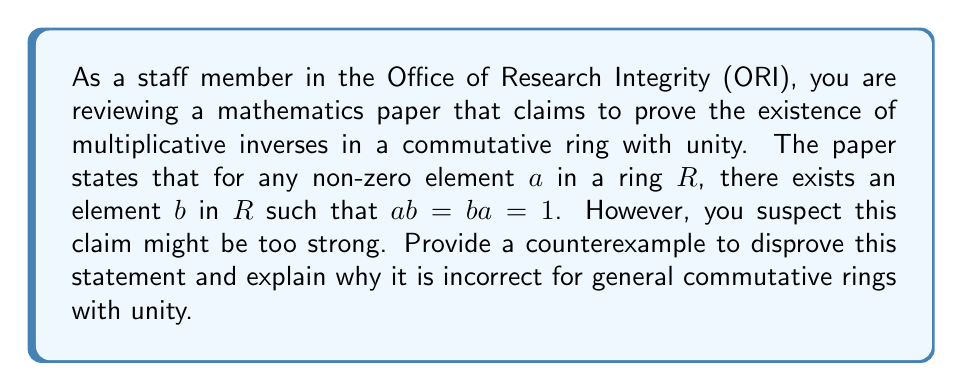Could you help me with this problem? To disprove the statement, we need to find a commutative ring with unity where not every non-zero element has a multiplicative inverse. Let's consider the ring of integers $\mathbb{Z}$ under standard addition and multiplication.

1. $\mathbb{Z}$ is a commutative ring with unity:
   - It is closed under addition and multiplication
   - Addition and multiplication are associative and commutative
   - Distributive property holds
   - $0$ is the additive identity
   - $1$ is the multiplicative identity (unity)

2. Consider the element $2 \in \mathbb{Z}$:
   - For $2$ to have a multiplicative inverse, we need to find an integer $x$ such that $2x = 1$
   - However, there is no integer $x$ that satisfies this equation

3. The multiplicative inverse of $2$, if it existed, would be $\frac{1}{2}$:
   $$2 \cdot \frac{1}{2} = 1$$
   But $\frac{1}{2} \notin \mathbb{Z}$

4. In fact, in $\mathbb{Z}$, only $1$ and $-1$ have multiplicative inverses:
   $$1 \cdot 1 = 1 \quad \text{and} \quad (-1) \cdot (-1) = 1$$

This counterexample demonstrates that the claim in the paper is incorrect. The existence of multiplicative inverses for all non-zero elements is a property of fields, not general commutative rings with unity. Rings that have this property are called division rings or skew fields, and commutative division rings are fields.
Answer: The statement is incorrect. A counterexample is the ring of integers $\mathbb{Z}$, where elements like $2$ do not have multiplicative inverses within the ring. 